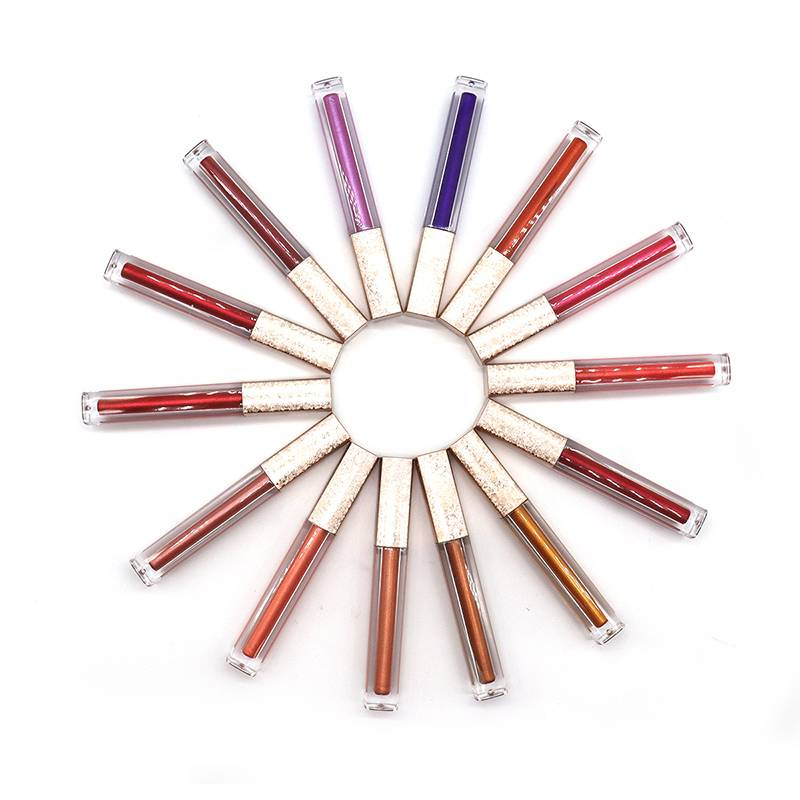Which gloss tube appears to have the most shimmer based on the reflection and light in the image? The gloss tube at the top right corner, with a deep, almost wine-colored hue, appears to have a significant amount of shimmer. The light reflections on the tube suggest the presence of finely milled glitter particles, which would likely translate to a sparkling effect when applied. 